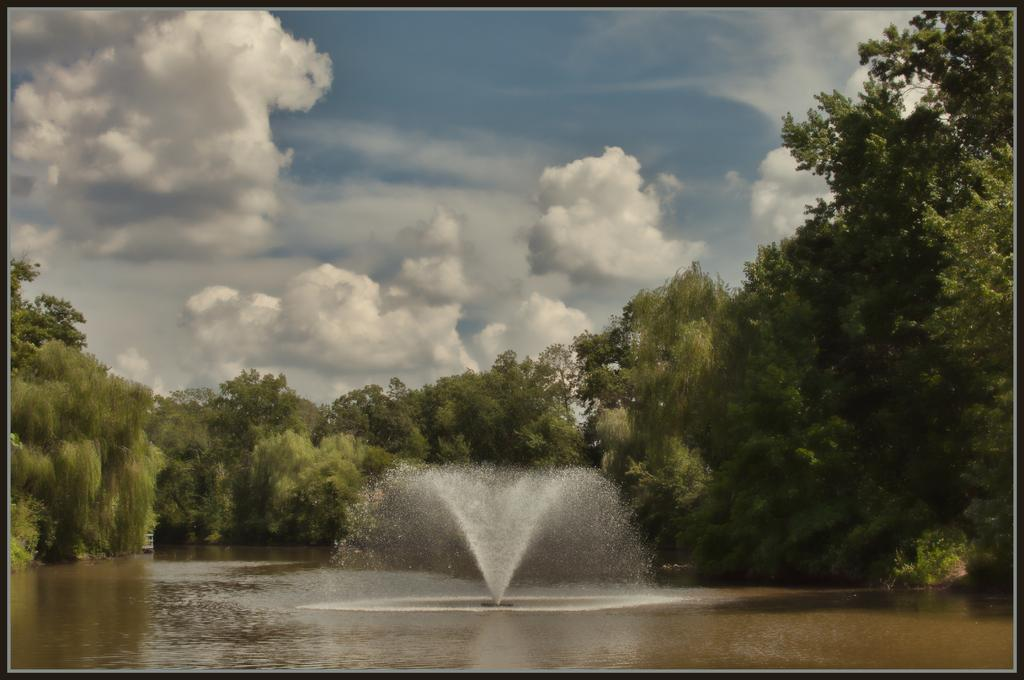What is the primary element in the image? There is water in the image. What structure is present in the water? There is a fountain in the image. What can be seen in the background of the image? There are trees in the background of the image. How would you describe the sky in the image? The sky is visible in the image and appears to be cloudy. What type of locket can be seen hanging from the fountain in the image? There is no locket present in the image; it features a fountain in the water. What thought process is the water going through in the image? The water does not have a thought process, as it is an inanimate object. 